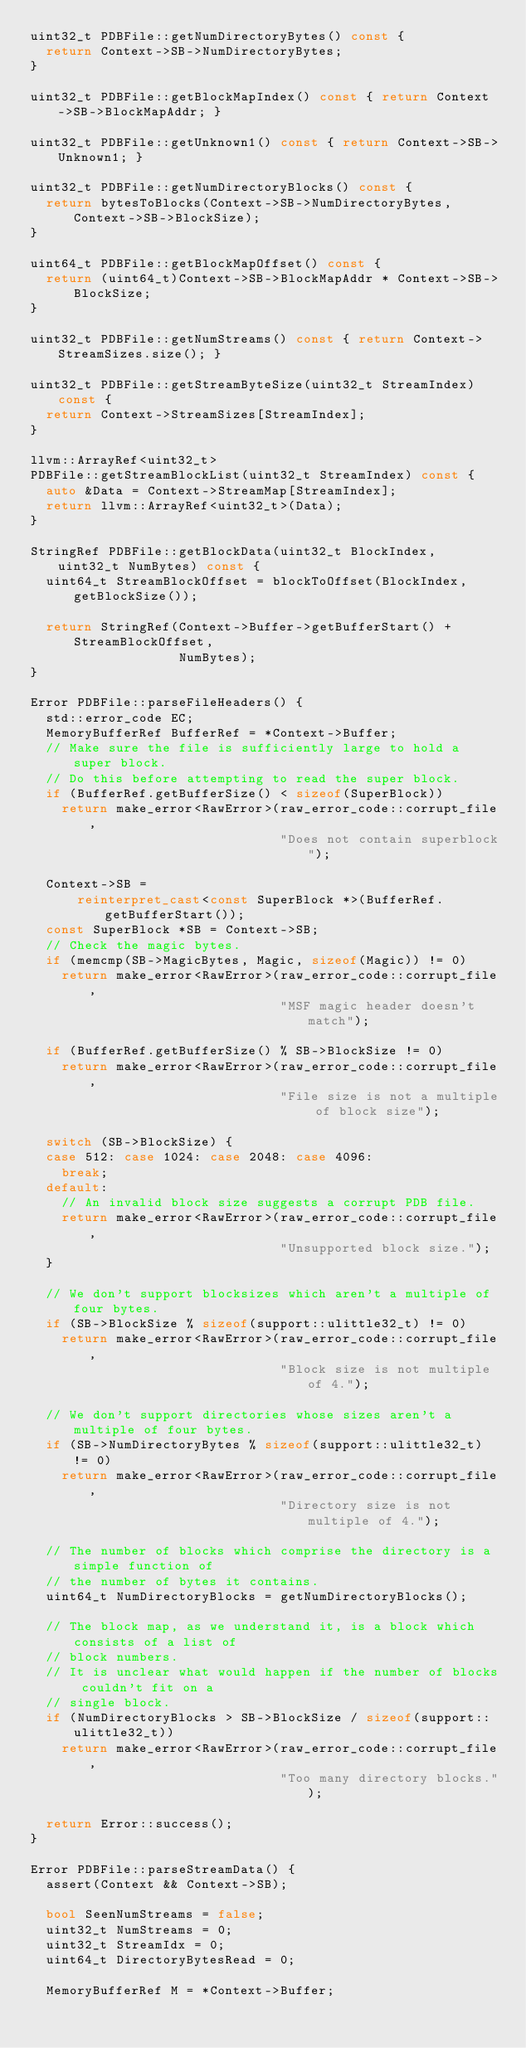Convert code to text. <code><loc_0><loc_0><loc_500><loc_500><_C++_>uint32_t PDBFile::getNumDirectoryBytes() const {
  return Context->SB->NumDirectoryBytes;
}

uint32_t PDBFile::getBlockMapIndex() const { return Context->SB->BlockMapAddr; }

uint32_t PDBFile::getUnknown1() const { return Context->SB->Unknown1; }

uint32_t PDBFile::getNumDirectoryBlocks() const {
  return bytesToBlocks(Context->SB->NumDirectoryBytes, Context->SB->BlockSize);
}

uint64_t PDBFile::getBlockMapOffset() const {
  return (uint64_t)Context->SB->BlockMapAddr * Context->SB->BlockSize;
}

uint32_t PDBFile::getNumStreams() const { return Context->StreamSizes.size(); }

uint32_t PDBFile::getStreamByteSize(uint32_t StreamIndex) const {
  return Context->StreamSizes[StreamIndex];
}

llvm::ArrayRef<uint32_t>
PDBFile::getStreamBlockList(uint32_t StreamIndex) const {
  auto &Data = Context->StreamMap[StreamIndex];
  return llvm::ArrayRef<uint32_t>(Data);
}

StringRef PDBFile::getBlockData(uint32_t BlockIndex, uint32_t NumBytes) const {
  uint64_t StreamBlockOffset = blockToOffset(BlockIndex, getBlockSize());

  return StringRef(Context->Buffer->getBufferStart() + StreamBlockOffset,
                   NumBytes);
}

Error PDBFile::parseFileHeaders() {
  std::error_code EC;
  MemoryBufferRef BufferRef = *Context->Buffer;
  // Make sure the file is sufficiently large to hold a super block.
  // Do this before attempting to read the super block.
  if (BufferRef.getBufferSize() < sizeof(SuperBlock))
    return make_error<RawError>(raw_error_code::corrupt_file,
                                "Does not contain superblock");

  Context->SB =
      reinterpret_cast<const SuperBlock *>(BufferRef.getBufferStart());
  const SuperBlock *SB = Context->SB;
  // Check the magic bytes.
  if (memcmp(SB->MagicBytes, Magic, sizeof(Magic)) != 0)
    return make_error<RawError>(raw_error_code::corrupt_file,
                                "MSF magic header doesn't match");

  if (BufferRef.getBufferSize() % SB->BlockSize != 0)
    return make_error<RawError>(raw_error_code::corrupt_file,
                                "File size is not a multiple of block size");

  switch (SB->BlockSize) {
  case 512: case 1024: case 2048: case 4096:
    break;
  default:
    // An invalid block size suggests a corrupt PDB file.
    return make_error<RawError>(raw_error_code::corrupt_file,
                                "Unsupported block size.");
  }

  // We don't support blocksizes which aren't a multiple of four bytes.
  if (SB->BlockSize % sizeof(support::ulittle32_t) != 0)
    return make_error<RawError>(raw_error_code::corrupt_file,
                                "Block size is not multiple of 4.");

  // We don't support directories whose sizes aren't a multiple of four bytes.
  if (SB->NumDirectoryBytes % sizeof(support::ulittle32_t) != 0)
    return make_error<RawError>(raw_error_code::corrupt_file,
                                "Directory size is not multiple of 4.");

  // The number of blocks which comprise the directory is a simple function of
  // the number of bytes it contains.
  uint64_t NumDirectoryBlocks = getNumDirectoryBlocks();

  // The block map, as we understand it, is a block which consists of a list of
  // block numbers.
  // It is unclear what would happen if the number of blocks couldn't fit on a
  // single block.
  if (NumDirectoryBlocks > SB->BlockSize / sizeof(support::ulittle32_t))
    return make_error<RawError>(raw_error_code::corrupt_file,
                                "Too many directory blocks.");

  return Error::success();
}

Error PDBFile::parseStreamData() {
  assert(Context && Context->SB);

  bool SeenNumStreams = false;
  uint32_t NumStreams = 0;
  uint32_t StreamIdx = 0;
  uint64_t DirectoryBytesRead = 0;

  MemoryBufferRef M = *Context->Buffer;</code> 